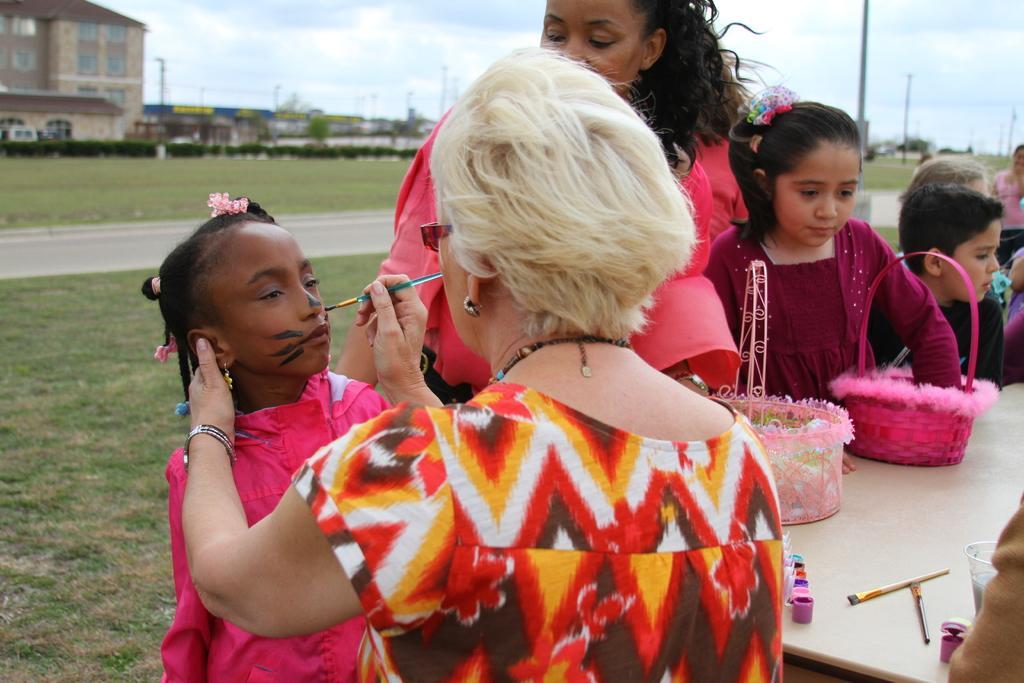Describe this image in one or two sentences. In this image there is an old lady holding a painting brush in her hand and she is painted on the face of a girl, beside the girl there, there are a few more people standing, in front of them there is a table with painting, two baskets, brushes and glass on the table. In the background there is a surface of the grass, trees, poles and buildings. 